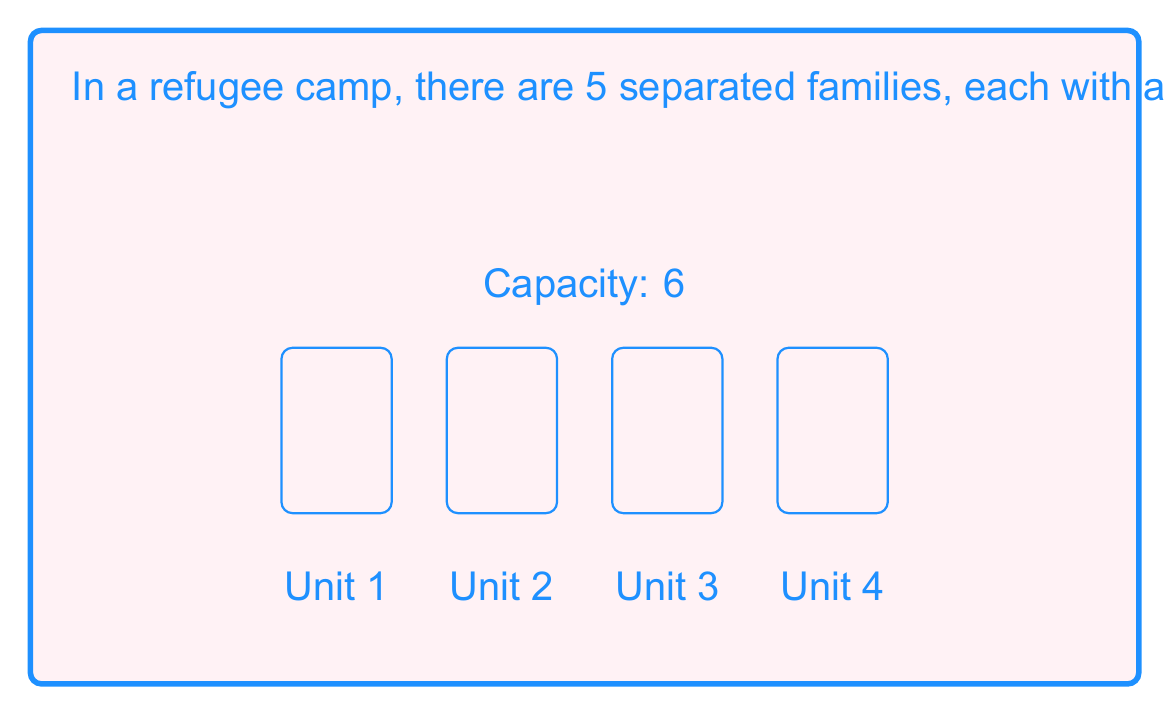What is the answer to this math problem? Let's approach this step-by-step:

1) First, we need to consider the constraints:
   - There are 5 families with sizes 2, 3, 4, 5, and 6.
   - There are 4 housing units, each with a capacity of 6.
   - Families must stay together in the same unit.

2) We can start by listing out all possible valid combinations of families that can fit in a single unit:
   - (2), (3), (4), (5), (6)
   - (2,3), (2,4)

3) Now, we need to distribute these combinations among the 4 units. This is a partition problem.

4) Let's use generating functions to solve this. Each term in our generating function will represent a housing unit, and the coefficient of $x^n$ in the expanded function will represent the number of ways to distribute families totaling n members.

5) Our generating function is:
   $$(1 + x^2 + x^3 + x^4 + x^5 + x^6 + x^5 + x^6)^4$$

   Where $(1 + x^2 + x^3 + x^4 + x^5 + x^6 + x^5 + x^6)$ represents the possible ways to fill a single unit (including leaving it empty).

6) We're interested in the coefficient of $x^{20}$ in this expanded function, as the total number of family members is $2+3+4+5+6 = 20$.

7) Expanding this function and finding the coefficient of $x^{20}$ gives us 65.

Therefore, there are 65 unique ways to distribute the families among the housing units.
Answer: 65 